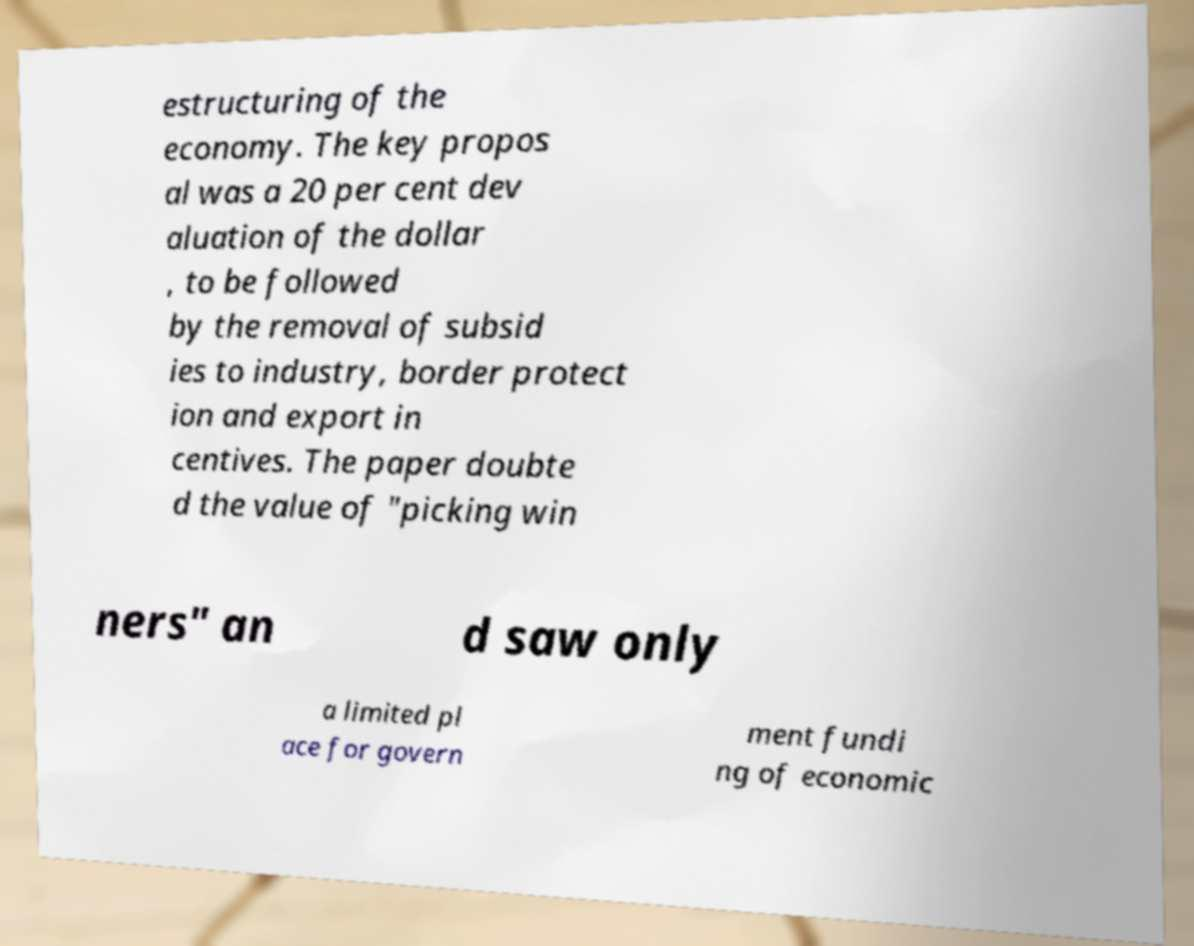What messages or text are displayed in this image? I need them in a readable, typed format. estructuring of the economy. The key propos al was a 20 per cent dev aluation of the dollar , to be followed by the removal of subsid ies to industry, border protect ion and export in centives. The paper doubte d the value of "picking win ners" an d saw only a limited pl ace for govern ment fundi ng of economic 